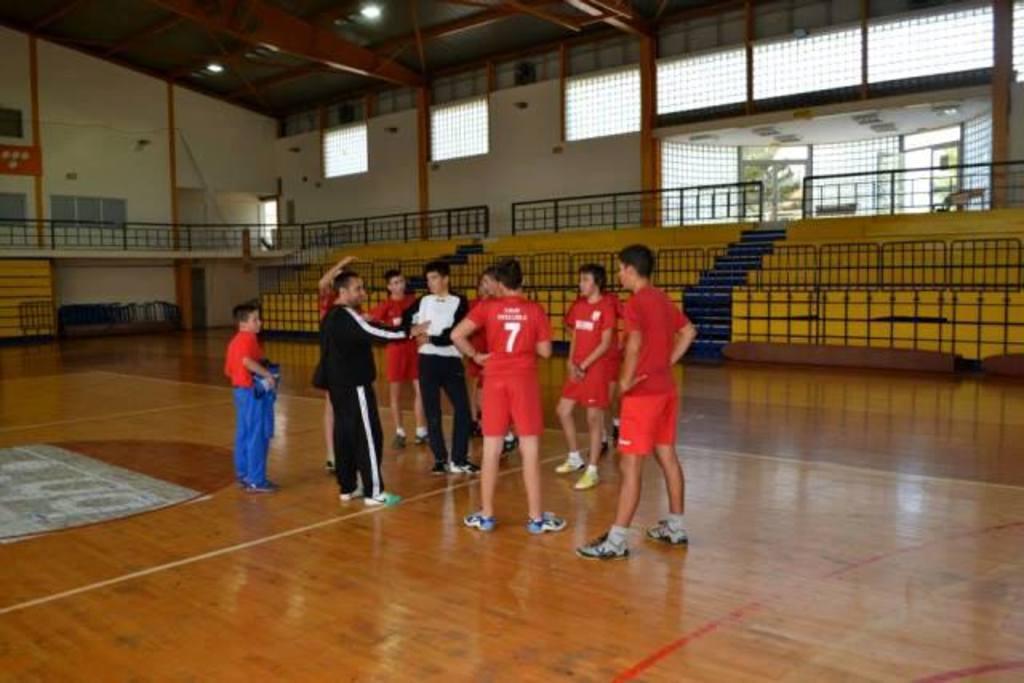Please provide a concise description of this image. In this picture, we see the men are sanding and they are talking about something. The boy in the red T-shirt is standing and he is holding something in his hand. In the background, we see the railing, staircase and the benches. Behind that, we see the railing and the wall. On the right side, we see the glass door from which we can see the tree. This picture might be clicked in the indoor stadium. 